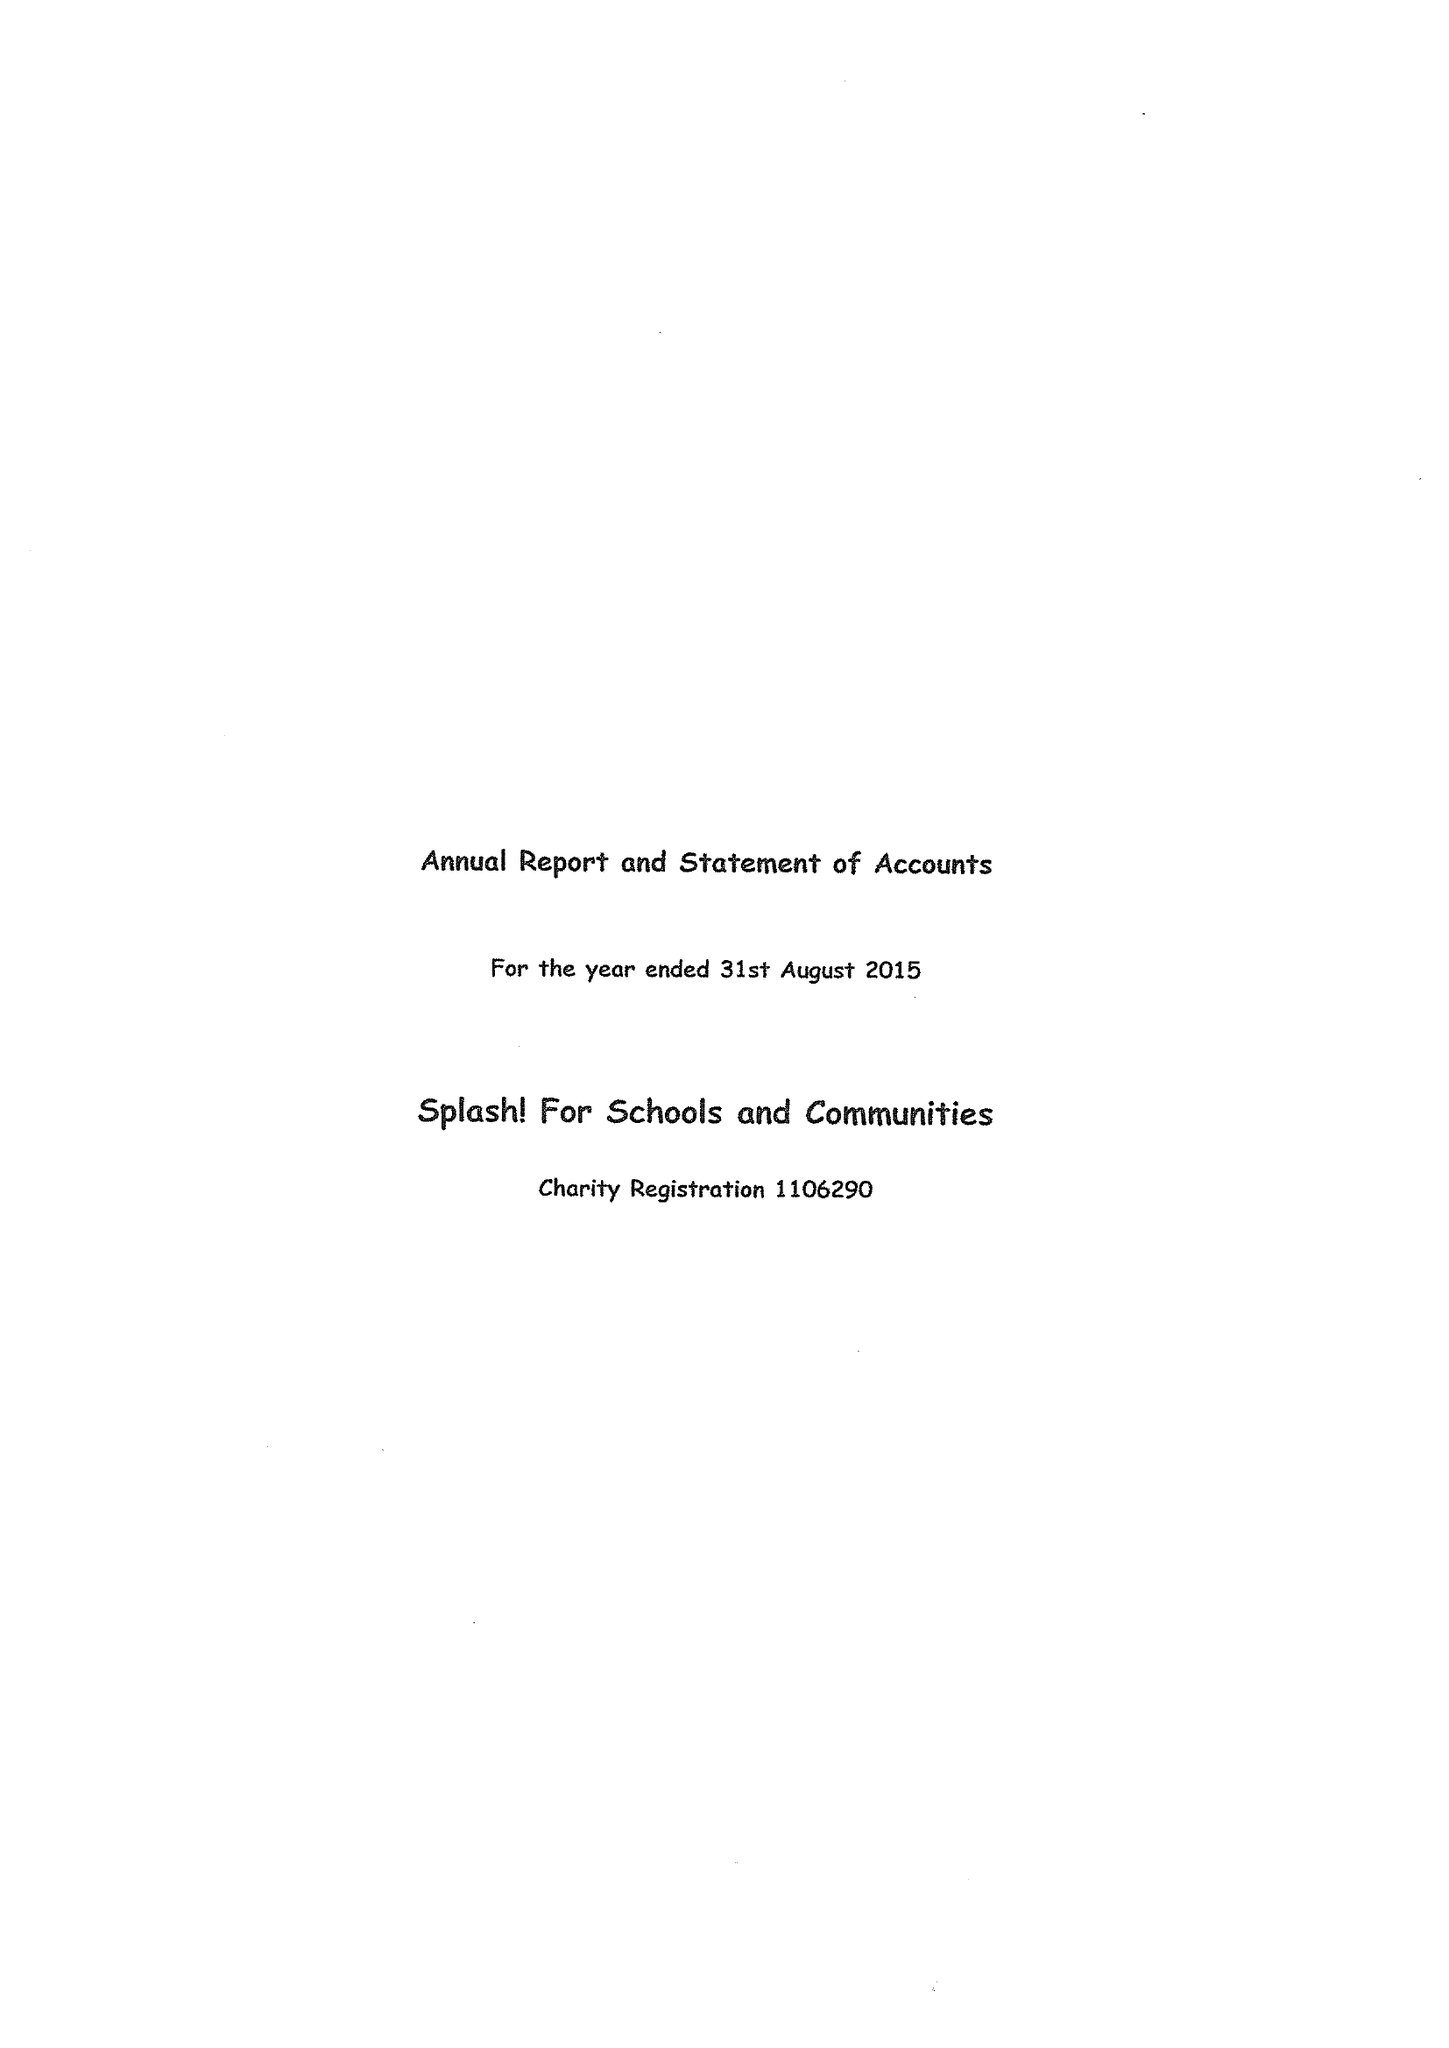What is the value for the address__postcode?
Answer the question using a single word or phrase. RH20 3JX 